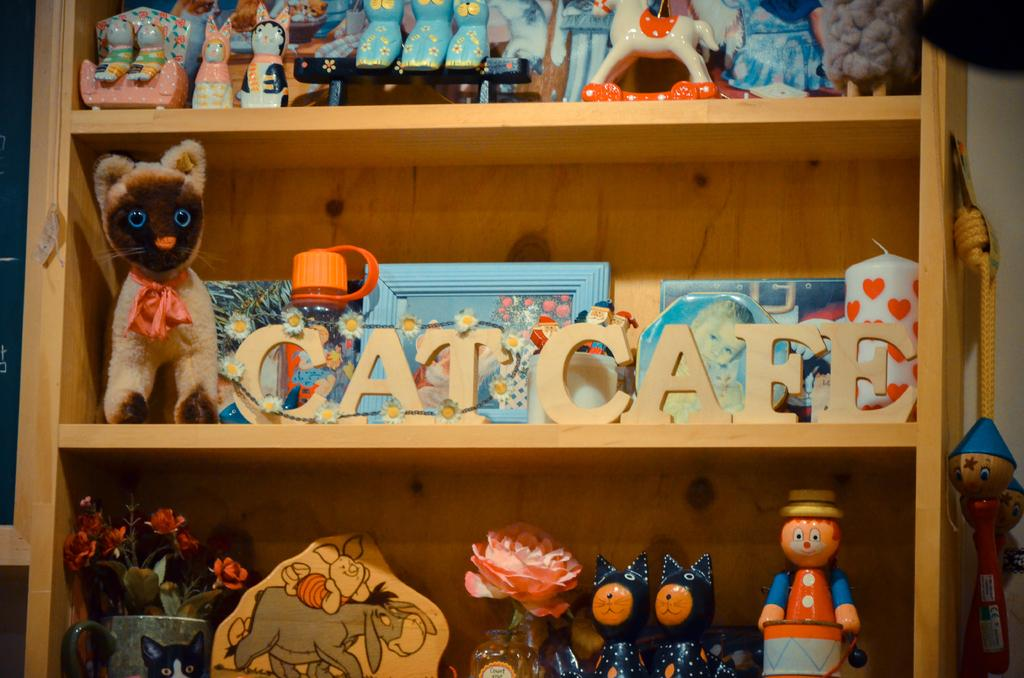What type of furniture is present in the image? There is a cupboard in the image. What items can be found inside the cupboard? The cupboard contains toys and flower vases. What is located behind the cupboard? There is a wall behind the cupboard. How many dogs are sitting on top of the cupboard in the image? There are no dogs present in the image; it only features a cupboard with toys and flower vases. 